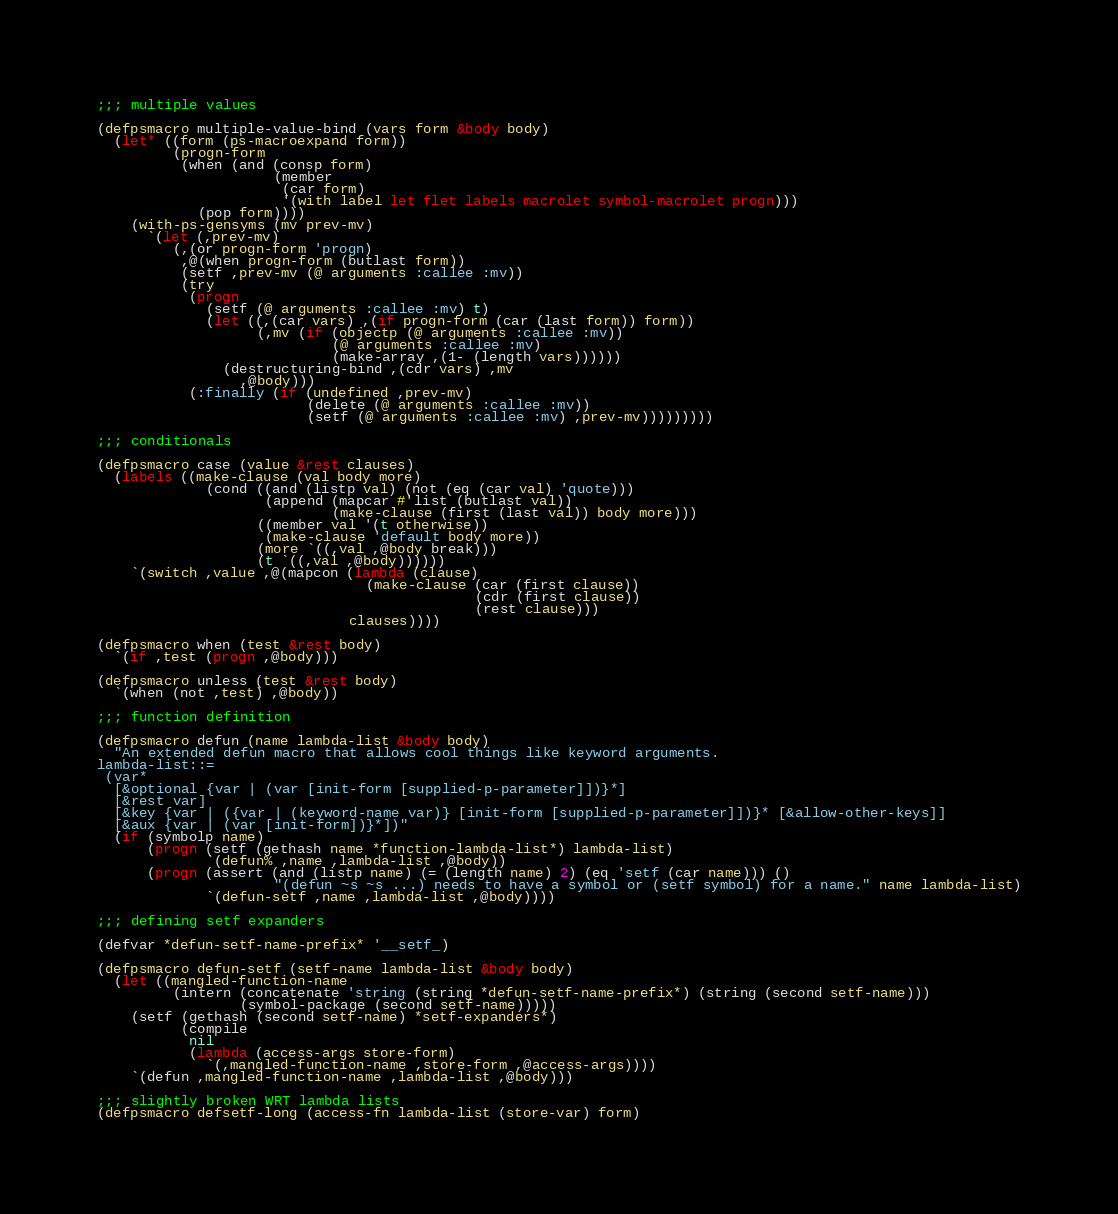<code> <loc_0><loc_0><loc_500><loc_500><_Lisp_>
;;; multiple values

(defpsmacro multiple-value-bind (vars form &body body)
  (let* ((form (ps-macroexpand form))
         (progn-form
          (when (and (consp form)
                     (member
                      (car form)
                      '(with label let flet labels macrolet symbol-macrolet progn)))
            (pop form))))
    (with-ps-gensyms (mv prev-mv)
      `(let (,prev-mv)
         (,(or progn-form 'progn)
          ,@(when progn-form (butlast form))
          (setf ,prev-mv (@ arguments :callee :mv))
          (try
           (progn
             (setf (@ arguments :callee :mv) t)
             (let ((,(car vars) ,(if progn-form (car (last form)) form))
                   (,mv (if (objectp (@ arguments :callee :mv))
                            (@ arguments :callee :mv)
                            (make-array ,(1- (length vars))))))
               (destructuring-bind ,(cdr vars) ,mv
                 ,@body)))
           (:finally (if (undefined ,prev-mv)
                         (delete (@ arguments :callee :mv))
                         (setf (@ arguments :callee :mv) ,prev-mv)))))))))

;;; conditionals

(defpsmacro case (value &rest clauses)
  (labels ((make-clause (val body more)
             (cond ((and (listp val) (not (eq (car val) 'quote)))
                    (append (mapcar #'list (butlast val))
                            (make-clause (first (last val)) body more)))
                   ((member val '(t otherwise))
                    (make-clause 'default body more))
                   (more `((,val ,@body break)))
                   (t `((,val ,@body))))))
    `(switch ,value ,@(mapcon (lambda (clause)
                                (make-clause (car (first clause))
                                             (cdr (first clause))
                                             (rest clause)))
                              clauses))))

(defpsmacro when (test &rest body)
  `(if ,test (progn ,@body)))

(defpsmacro unless (test &rest body)
  `(when (not ,test) ,@body))

;;; function definition

(defpsmacro defun (name lambda-list &body body)
  "An extended defun macro that allows cool things like keyword arguments.
lambda-list::=
 (var*
  [&optional {var | (var [init-form [supplied-p-parameter]])}*]
  [&rest var]
  [&key {var | ({var | (keyword-name var)} [init-form [supplied-p-parameter]])}* [&allow-other-keys]]
  [&aux {var | (var [init-form])}*])"
  (if (symbolp name)
      (progn (setf (gethash name *function-lambda-list*) lambda-list)
             `(defun% ,name ,lambda-list ,@body))
      (progn (assert (and (listp name) (= (length name) 2) (eq 'setf (car name))) ()
                     "(defun ~s ~s ...) needs to have a symbol or (setf symbol) for a name." name lambda-list)
             `(defun-setf ,name ,lambda-list ,@body))))

;;; defining setf expanders

(defvar *defun-setf-name-prefix* '__setf_)

(defpsmacro defun-setf (setf-name lambda-list &body body)
  (let ((mangled-function-name
         (intern (concatenate 'string (string *defun-setf-name-prefix*) (string (second setf-name)))
                 (symbol-package (second setf-name)))))
    (setf (gethash (second setf-name) *setf-expanders*)
          (compile
           nil
           (lambda (access-args store-form)
             `(,mangled-function-name ,store-form ,@access-args))))
    `(defun ,mangled-function-name ,lambda-list ,@body)))

;;; slightly broken WRT lambda lists
(defpsmacro defsetf-long (access-fn lambda-list (store-var) form)</code> 